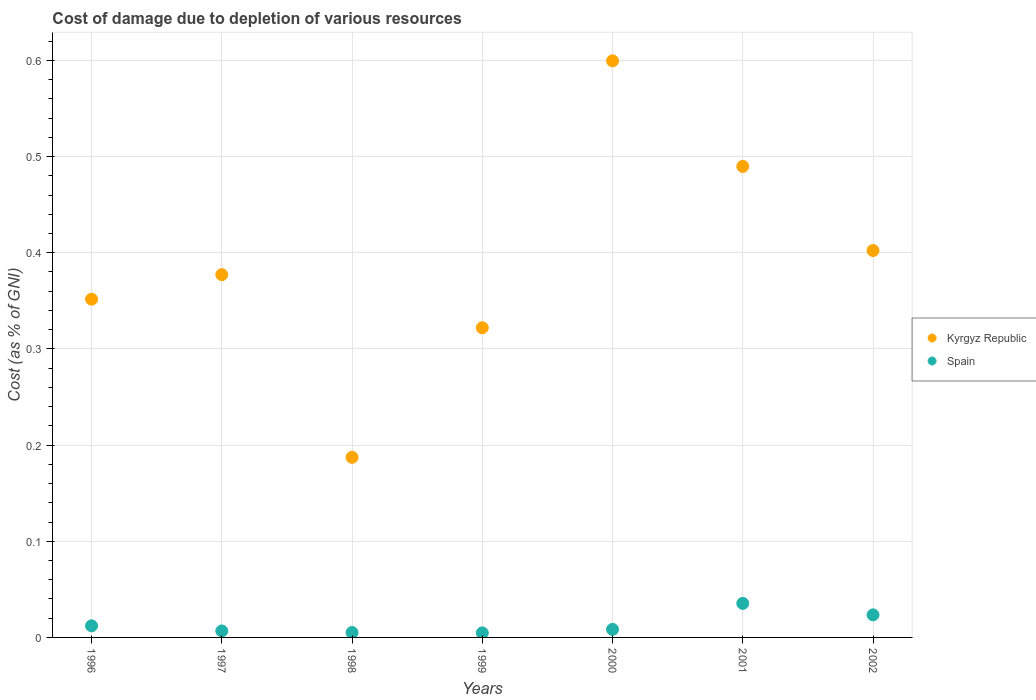How many different coloured dotlines are there?
Offer a terse response. 2. What is the cost of damage caused due to the depletion of various resources in Kyrgyz Republic in 1999?
Your response must be concise. 0.32. Across all years, what is the maximum cost of damage caused due to the depletion of various resources in Spain?
Ensure brevity in your answer.  0.04. Across all years, what is the minimum cost of damage caused due to the depletion of various resources in Spain?
Your answer should be compact. 0. In which year was the cost of damage caused due to the depletion of various resources in Kyrgyz Republic minimum?
Give a very brief answer. 1998. What is the total cost of damage caused due to the depletion of various resources in Spain in the graph?
Provide a succinct answer. 0.1. What is the difference between the cost of damage caused due to the depletion of various resources in Kyrgyz Republic in 1998 and that in 2001?
Your answer should be very brief. -0.3. What is the difference between the cost of damage caused due to the depletion of various resources in Kyrgyz Republic in 2000 and the cost of damage caused due to the depletion of various resources in Spain in 2001?
Ensure brevity in your answer.  0.56. What is the average cost of damage caused due to the depletion of various resources in Kyrgyz Republic per year?
Give a very brief answer. 0.39. In the year 1996, what is the difference between the cost of damage caused due to the depletion of various resources in Kyrgyz Republic and cost of damage caused due to the depletion of various resources in Spain?
Your answer should be very brief. 0.34. What is the ratio of the cost of damage caused due to the depletion of various resources in Spain in 2000 to that in 2002?
Offer a very short reply. 0.36. Is the cost of damage caused due to the depletion of various resources in Spain in 1998 less than that in 2000?
Offer a terse response. Yes. What is the difference between the highest and the second highest cost of damage caused due to the depletion of various resources in Kyrgyz Republic?
Your answer should be compact. 0.11. What is the difference between the highest and the lowest cost of damage caused due to the depletion of various resources in Spain?
Give a very brief answer. 0.03. Is the sum of the cost of damage caused due to the depletion of various resources in Kyrgyz Republic in 2000 and 2002 greater than the maximum cost of damage caused due to the depletion of various resources in Spain across all years?
Your answer should be compact. Yes. Is the cost of damage caused due to the depletion of various resources in Kyrgyz Republic strictly less than the cost of damage caused due to the depletion of various resources in Spain over the years?
Provide a short and direct response. No. How many dotlines are there?
Make the answer very short. 2. How many years are there in the graph?
Your response must be concise. 7. What is the difference between two consecutive major ticks on the Y-axis?
Keep it short and to the point. 0.1. Are the values on the major ticks of Y-axis written in scientific E-notation?
Provide a short and direct response. No. Does the graph contain any zero values?
Your response must be concise. No. Does the graph contain grids?
Offer a terse response. Yes. Where does the legend appear in the graph?
Offer a very short reply. Center right. How are the legend labels stacked?
Your answer should be compact. Vertical. What is the title of the graph?
Keep it short and to the point. Cost of damage due to depletion of various resources. What is the label or title of the Y-axis?
Your answer should be very brief. Cost (as % of GNI). What is the Cost (as % of GNI) in Kyrgyz Republic in 1996?
Your response must be concise. 0.35. What is the Cost (as % of GNI) in Spain in 1996?
Offer a terse response. 0.01. What is the Cost (as % of GNI) of Kyrgyz Republic in 1997?
Provide a short and direct response. 0.38. What is the Cost (as % of GNI) in Spain in 1997?
Make the answer very short. 0.01. What is the Cost (as % of GNI) in Kyrgyz Republic in 1998?
Your response must be concise. 0.19. What is the Cost (as % of GNI) in Spain in 1998?
Make the answer very short. 0.01. What is the Cost (as % of GNI) of Kyrgyz Republic in 1999?
Keep it short and to the point. 0.32. What is the Cost (as % of GNI) in Spain in 1999?
Give a very brief answer. 0. What is the Cost (as % of GNI) of Kyrgyz Republic in 2000?
Offer a very short reply. 0.6. What is the Cost (as % of GNI) of Spain in 2000?
Offer a very short reply. 0.01. What is the Cost (as % of GNI) in Kyrgyz Republic in 2001?
Offer a terse response. 0.49. What is the Cost (as % of GNI) of Spain in 2001?
Provide a succinct answer. 0.04. What is the Cost (as % of GNI) in Kyrgyz Republic in 2002?
Offer a terse response. 0.4. What is the Cost (as % of GNI) in Spain in 2002?
Your answer should be compact. 0.02. Across all years, what is the maximum Cost (as % of GNI) of Kyrgyz Republic?
Provide a succinct answer. 0.6. Across all years, what is the maximum Cost (as % of GNI) in Spain?
Ensure brevity in your answer.  0.04. Across all years, what is the minimum Cost (as % of GNI) in Kyrgyz Republic?
Offer a terse response. 0.19. Across all years, what is the minimum Cost (as % of GNI) of Spain?
Give a very brief answer. 0. What is the total Cost (as % of GNI) of Kyrgyz Republic in the graph?
Your answer should be compact. 2.73. What is the total Cost (as % of GNI) of Spain in the graph?
Provide a succinct answer. 0.1. What is the difference between the Cost (as % of GNI) of Kyrgyz Republic in 1996 and that in 1997?
Provide a short and direct response. -0.03. What is the difference between the Cost (as % of GNI) of Spain in 1996 and that in 1997?
Provide a short and direct response. 0.01. What is the difference between the Cost (as % of GNI) in Kyrgyz Republic in 1996 and that in 1998?
Give a very brief answer. 0.16. What is the difference between the Cost (as % of GNI) in Spain in 1996 and that in 1998?
Offer a very short reply. 0.01. What is the difference between the Cost (as % of GNI) in Kyrgyz Republic in 1996 and that in 1999?
Make the answer very short. 0.03. What is the difference between the Cost (as % of GNI) in Spain in 1996 and that in 1999?
Your response must be concise. 0.01. What is the difference between the Cost (as % of GNI) of Kyrgyz Republic in 1996 and that in 2000?
Make the answer very short. -0.25. What is the difference between the Cost (as % of GNI) of Spain in 1996 and that in 2000?
Your answer should be very brief. 0. What is the difference between the Cost (as % of GNI) in Kyrgyz Republic in 1996 and that in 2001?
Offer a terse response. -0.14. What is the difference between the Cost (as % of GNI) of Spain in 1996 and that in 2001?
Give a very brief answer. -0.02. What is the difference between the Cost (as % of GNI) in Kyrgyz Republic in 1996 and that in 2002?
Your response must be concise. -0.05. What is the difference between the Cost (as % of GNI) of Spain in 1996 and that in 2002?
Provide a succinct answer. -0.01. What is the difference between the Cost (as % of GNI) of Kyrgyz Republic in 1997 and that in 1998?
Offer a very short reply. 0.19. What is the difference between the Cost (as % of GNI) in Spain in 1997 and that in 1998?
Offer a very short reply. 0. What is the difference between the Cost (as % of GNI) of Kyrgyz Republic in 1997 and that in 1999?
Make the answer very short. 0.06. What is the difference between the Cost (as % of GNI) of Spain in 1997 and that in 1999?
Offer a terse response. 0. What is the difference between the Cost (as % of GNI) of Kyrgyz Republic in 1997 and that in 2000?
Offer a very short reply. -0.22. What is the difference between the Cost (as % of GNI) in Spain in 1997 and that in 2000?
Your answer should be very brief. -0. What is the difference between the Cost (as % of GNI) in Kyrgyz Republic in 1997 and that in 2001?
Give a very brief answer. -0.11. What is the difference between the Cost (as % of GNI) in Spain in 1997 and that in 2001?
Your answer should be compact. -0.03. What is the difference between the Cost (as % of GNI) of Kyrgyz Republic in 1997 and that in 2002?
Provide a short and direct response. -0.03. What is the difference between the Cost (as % of GNI) of Spain in 1997 and that in 2002?
Provide a succinct answer. -0.02. What is the difference between the Cost (as % of GNI) in Kyrgyz Republic in 1998 and that in 1999?
Ensure brevity in your answer.  -0.13. What is the difference between the Cost (as % of GNI) in Kyrgyz Republic in 1998 and that in 2000?
Give a very brief answer. -0.41. What is the difference between the Cost (as % of GNI) of Spain in 1998 and that in 2000?
Provide a succinct answer. -0. What is the difference between the Cost (as % of GNI) of Kyrgyz Republic in 1998 and that in 2001?
Ensure brevity in your answer.  -0.3. What is the difference between the Cost (as % of GNI) in Spain in 1998 and that in 2001?
Keep it short and to the point. -0.03. What is the difference between the Cost (as % of GNI) of Kyrgyz Republic in 1998 and that in 2002?
Make the answer very short. -0.21. What is the difference between the Cost (as % of GNI) of Spain in 1998 and that in 2002?
Offer a very short reply. -0.02. What is the difference between the Cost (as % of GNI) in Kyrgyz Republic in 1999 and that in 2000?
Make the answer very short. -0.28. What is the difference between the Cost (as % of GNI) of Spain in 1999 and that in 2000?
Provide a succinct answer. -0. What is the difference between the Cost (as % of GNI) in Kyrgyz Republic in 1999 and that in 2001?
Provide a short and direct response. -0.17. What is the difference between the Cost (as % of GNI) of Spain in 1999 and that in 2001?
Provide a succinct answer. -0.03. What is the difference between the Cost (as % of GNI) in Kyrgyz Republic in 1999 and that in 2002?
Offer a terse response. -0.08. What is the difference between the Cost (as % of GNI) in Spain in 1999 and that in 2002?
Offer a terse response. -0.02. What is the difference between the Cost (as % of GNI) in Kyrgyz Republic in 2000 and that in 2001?
Give a very brief answer. 0.11. What is the difference between the Cost (as % of GNI) in Spain in 2000 and that in 2001?
Give a very brief answer. -0.03. What is the difference between the Cost (as % of GNI) of Kyrgyz Republic in 2000 and that in 2002?
Your response must be concise. 0.2. What is the difference between the Cost (as % of GNI) in Spain in 2000 and that in 2002?
Make the answer very short. -0.02. What is the difference between the Cost (as % of GNI) of Kyrgyz Republic in 2001 and that in 2002?
Give a very brief answer. 0.09. What is the difference between the Cost (as % of GNI) in Spain in 2001 and that in 2002?
Your answer should be very brief. 0.01. What is the difference between the Cost (as % of GNI) in Kyrgyz Republic in 1996 and the Cost (as % of GNI) in Spain in 1997?
Give a very brief answer. 0.34. What is the difference between the Cost (as % of GNI) in Kyrgyz Republic in 1996 and the Cost (as % of GNI) in Spain in 1998?
Keep it short and to the point. 0.35. What is the difference between the Cost (as % of GNI) in Kyrgyz Republic in 1996 and the Cost (as % of GNI) in Spain in 1999?
Your answer should be compact. 0.35. What is the difference between the Cost (as % of GNI) in Kyrgyz Republic in 1996 and the Cost (as % of GNI) in Spain in 2000?
Offer a terse response. 0.34. What is the difference between the Cost (as % of GNI) of Kyrgyz Republic in 1996 and the Cost (as % of GNI) of Spain in 2001?
Your answer should be compact. 0.32. What is the difference between the Cost (as % of GNI) in Kyrgyz Republic in 1996 and the Cost (as % of GNI) in Spain in 2002?
Offer a terse response. 0.33. What is the difference between the Cost (as % of GNI) in Kyrgyz Republic in 1997 and the Cost (as % of GNI) in Spain in 1998?
Your answer should be very brief. 0.37. What is the difference between the Cost (as % of GNI) in Kyrgyz Republic in 1997 and the Cost (as % of GNI) in Spain in 1999?
Provide a short and direct response. 0.37. What is the difference between the Cost (as % of GNI) of Kyrgyz Republic in 1997 and the Cost (as % of GNI) of Spain in 2000?
Give a very brief answer. 0.37. What is the difference between the Cost (as % of GNI) in Kyrgyz Republic in 1997 and the Cost (as % of GNI) in Spain in 2001?
Offer a very short reply. 0.34. What is the difference between the Cost (as % of GNI) of Kyrgyz Republic in 1997 and the Cost (as % of GNI) of Spain in 2002?
Offer a terse response. 0.35. What is the difference between the Cost (as % of GNI) of Kyrgyz Republic in 1998 and the Cost (as % of GNI) of Spain in 1999?
Provide a succinct answer. 0.18. What is the difference between the Cost (as % of GNI) of Kyrgyz Republic in 1998 and the Cost (as % of GNI) of Spain in 2000?
Make the answer very short. 0.18. What is the difference between the Cost (as % of GNI) in Kyrgyz Republic in 1998 and the Cost (as % of GNI) in Spain in 2001?
Ensure brevity in your answer.  0.15. What is the difference between the Cost (as % of GNI) in Kyrgyz Republic in 1998 and the Cost (as % of GNI) in Spain in 2002?
Your answer should be compact. 0.16. What is the difference between the Cost (as % of GNI) in Kyrgyz Republic in 1999 and the Cost (as % of GNI) in Spain in 2000?
Make the answer very short. 0.31. What is the difference between the Cost (as % of GNI) in Kyrgyz Republic in 1999 and the Cost (as % of GNI) in Spain in 2001?
Make the answer very short. 0.29. What is the difference between the Cost (as % of GNI) of Kyrgyz Republic in 1999 and the Cost (as % of GNI) of Spain in 2002?
Make the answer very short. 0.3. What is the difference between the Cost (as % of GNI) in Kyrgyz Republic in 2000 and the Cost (as % of GNI) in Spain in 2001?
Your answer should be compact. 0.56. What is the difference between the Cost (as % of GNI) of Kyrgyz Republic in 2000 and the Cost (as % of GNI) of Spain in 2002?
Give a very brief answer. 0.58. What is the difference between the Cost (as % of GNI) of Kyrgyz Republic in 2001 and the Cost (as % of GNI) of Spain in 2002?
Offer a terse response. 0.47. What is the average Cost (as % of GNI) in Kyrgyz Republic per year?
Provide a short and direct response. 0.39. What is the average Cost (as % of GNI) of Spain per year?
Ensure brevity in your answer.  0.01. In the year 1996, what is the difference between the Cost (as % of GNI) of Kyrgyz Republic and Cost (as % of GNI) of Spain?
Keep it short and to the point. 0.34. In the year 1997, what is the difference between the Cost (as % of GNI) in Kyrgyz Republic and Cost (as % of GNI) in Spain?
Offer a very short reply. 0.37. In the year 1998, what is the difference between the Cost (as % of GNI) in Kyrgyz Republic and Cost (as % of GNI) in Spain?
Your response must be concise. 0.18. In the year 1999, what is the difference between the Cost (as % of GNI) in Kyrgyz Republic and Cost (as % of GNI) in Spain?
Your answer should be compact. 0.32. In the year 2000, what is the difference between the Cost (as % of GNI) of Kyrgyz Republic and Cost (as % of GNI) of Spain?
Give a very brief answer. 0.59. In the year 2001, what is the difference between the Cost (as % of GNI) in Kyrgyz Republic and Cost (as % of GNI) in Spain?
Provide a succinct answer. 0.45. In the year 2002, what is the difference between the Cost (as % of GNI) of Kyrgyz Republic and Cost (as % of GNI) of Spain?
Keep it short and to the point. 0.38. What is the ratio of the Cost (as % of GNI) of Kyrgyz Republic in 1996 to that in 1997?
Keep it short and to the point. 0.93. What is the ratio of the Cost (as % of GNI) in Spain in 1996 to that in 1997?
Your answer should be very brief. 1.79. What is the ratio of the Cost (as % of GNI) of Kyrgyz Republic in 1996 to that in 1998?
Your answer should be compact. 1.88. What is the ratio of the Cost (as % of GNI) of Spain in 1996 to that in 1998?
Your answer should be compact. 2.37. What is the ratio of the Cost (as % of GNI) of Kyrgyz Republic in 1996 to that in 1999?
Provide a succinct answer. 1.09. What is the ratio of the Cost (as % of GNI) of Spain in 1996 to that in 1999?
Provide a succinct answer. 2.55. What is the ratio of the Cost (as % of GNI) of Kyrgyz Republic in 1996 to that in 2000?
Your answer should be very brief. 0.59. What is the ratio of the Cost (as % of GNI) in Spain in 1996 to that in 2000?
Keep it short and to the point. 1.44. What is the ratio of the Cost (as % of GNI) in Kyrgyz Republic in 1996 to that in 2001?
Your response must be concise. 0.72. What is the ratio of the Cost (as % of GNI) of Spain in 1996 to that in 2001?
Provide a succinct answer. 0.34. What is the ratio of the Cost (as % of GNI) in Kyrgyz Republic in 1996 to that in 2002?
Ensure brevity in your answer.  0.87. What is the ratio of the Cost (as % of GNI) of Spain in 1996 to that in 2002?
Offer a terse response. 0.51. What is the ratio of the Cost (as % of GNI) of Kyrgyz Republic in 1997 to that in 1998?
Your answer should be very brief. 2.01. What is the ratio of the Cost (as % of GNI) of Spain in 1997 to that in 1998?
Your response must be concise. 1.33. What is the ratio of the Cost (as % of GNI) in Kyrgyz Republic in 1997 to that in 1999?
Make the answer very short. 1.17. What is the ratio of the Cost (as % of GNI) of Spain in 1997 to that in 1999?
Make the answer very short. 1.43. What is the ratio of the Cost (as % of GNI) of Kyrgyz Republic in 1997 to that in 2000?
Offer a very short reply. 0.63. What is the ratio of the Cost (as % of GNI) in Spain in 1997 to that in 2000?
Offer a very short reply. 0.81. What is the ratio of the Cost (as % of GNI) of Kyrgyz Republic in 1997 to that in 2001?
Your answer should be compact. 0.77. What is the ratio of the Cost (as % of GNI) of Spain in 1997 to that in 2001?
Provide a succinct answer. 0.19. What is the ratio of the Cost (as % of GNI) of Kyrgyz Republic in 1997 to that in 2002?
Provide a short and direct response. 0.94. What is the ratio of the Cost (as % of GNI) in Spain in 1997 to that in 2002?
Give a very brief answer. 0.29. What is the ratio of the Cost (as % of GNI) of Kyrgyz Republic in 1998 to that in 1999?
Keep it short and to the point. 0.58. What is the ratio of the Cost (as % of GNI) of Spain in 1998 to that in 1999?
Your answer should be compact. 1.08. What is the ratio of the Cost (as % of GNI) of Kyrgyz Republic in 1998 to that in 2000?
Offer a terse response. 0.31. What is the ratio of the Cost (as % of GNI) of Spain in 1998 to that in 2000?
Offer a very short reply. 0.61. What is the ratio of the Cost (as % of GNI) of Kyrgyz Republic in 1998 to that in 2001?
Make the answer very short. 0.38. What is the ratio of the Cost (as % of GNI) in Spain in 1998 to that in 2001?
Ensure brevity in your answer.  0.14. What is the ratio of the Cost (as % of GNI) in Kyrgyz Republic in 1998 to that in 2002?
Your response must be concise. 0.47. What is the ratio of the Cost (as % of GNI) in Spain in 1998 to that in 2002?
Make the answer very short. 0.22. What is the ratio of the Cost (as % of GNI) of Kyrgyz Republic in 1999 to that in 2000?
Ensure brevity in your answer.  0.54. What is the ratio of the Cost (as % of GNI) of Spain in 1999 to that in 2000?
Make the answer very short. 0.56. What is the ratio of the Cost (as % of GNI) of Kyrgyz Republic in 1999 to that in 2001?
Offer a very short reply. 0.66. What is the ratio of the Cost (as % of GNI) of Spain in 1999 to that in 2001?
Make the answer very short. 0.13. What is the ratio of the Cost (as % of GNI) of Kyrgyz Republic in 1999 to that in 2002?
Provide a succinct answer. 0.8. What is the ratio of the Cost (as % of GNI) in Spain in 1999 to that in 2002?
Make the answer very short. 0.2. What is the ratio of the Cost (as % of GNI) of Kyrgyz Republic in 2000 to that in 2001?
Your response must be concise. 1.22. What is the ratio of the Cost (as % of GNI) in Spain in 2000 to that in 2001?
Provide a succinct answer. 0.24. What is the ratio of the Cost (as % of GNI) of Kyrgyz Republic in 2000 to that in 2002?
Offer a very short reply. 1.49. What is the ratio of the Cost (as % of GNI) of Spain in 2000 to that in 2002?
Keep it short and to the point. 0.36. What is the ratio of the Cost (as % of GNI) of Kyrgyz Republic in 2001 to that in 2002?
Your answer should be compact. 1.22. What is the ratio of the Cost (as % of GNI) in Spain in 2001 to that in 2002?
Offer a terse response. 1.51. What is the difference between the highest and the second highest Cost (as % of GNI) of Kyrgyz Republic?
Ensure brevity in your answer.  0.11. What is the difference between the highest and the second highest Cost (as % of GNI) of Spain?
Offer a terse response. 0.01. What is the difference between the highest and the lowest Cost (as % of GNI) in Kyrgyz Republic?
Your answer should be compact. 0.41. What is the difference between the highest and the lowest Cost (as % of GNI) in Spain?
Offer a terse response. 0.03. 